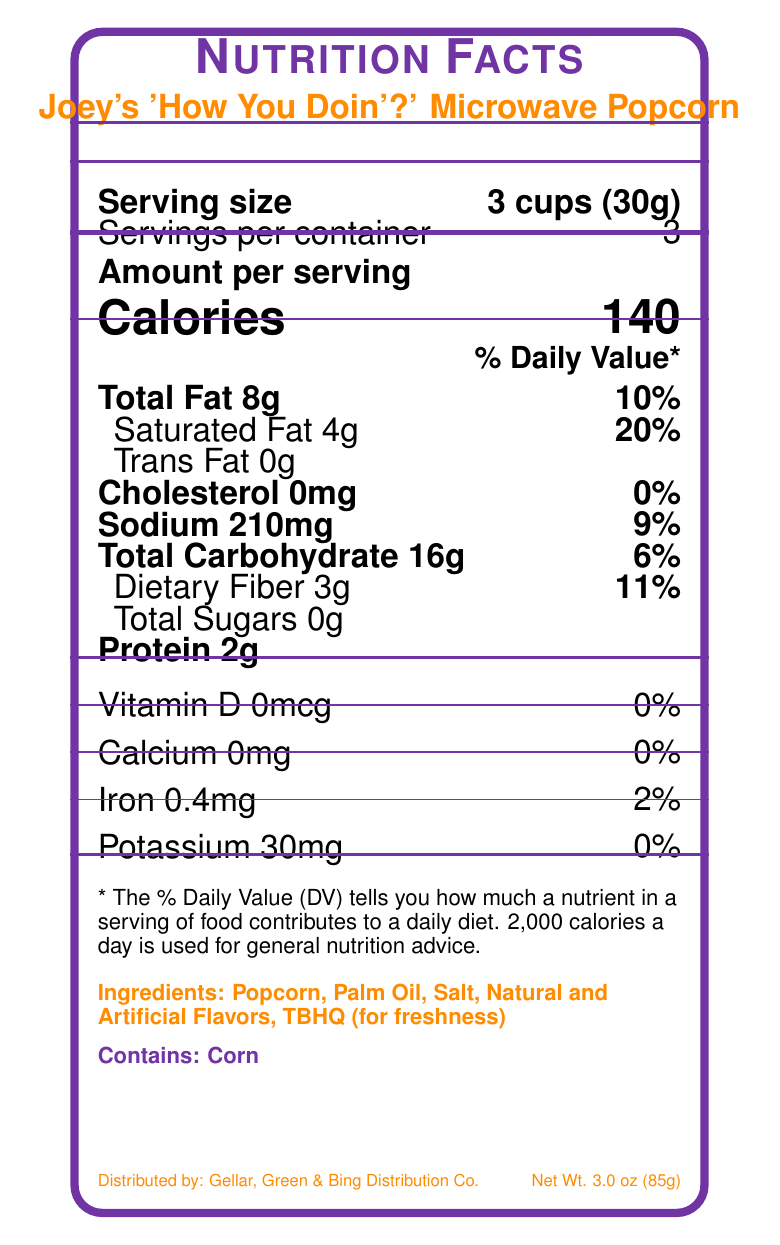how many calories are in one serving of Joey's 'How You Doin'?' Microwave Popcorn? The nutrition facts label states that there are 140 calories per serving.
Answer: 140 what is the serving size for Joey's 'How You Doin'?' Microwave Popcorn? The serving size is listed as 3 cups (30g) on the nutrition facts label.
Answer: 3 cups (30g) how much total fat is in one serving of this popcorn? According to the nutrition facts, each serving contains 8 grams of total fat.
Answer: 8g what percentage of the daily value does saturated fat in one serving represent? The nutrition label indicates that the saturated fat in one serving is 4g, which corresponds to 20% of the daily value.
Answer: 20% how much sodium is in one serving? The nutrition facts state that there are 210 milligrams of sodium in one serving.
Answer: 210mg list all the ingredients in Joey's 'How You Doin'?' Microwave Popcorn The ingredients are provided on the nutrition facts label.
Answer: Popcorn, Palm Oil, Salt, Natural and Artificial Flavors, TBHQ (for freshness) does this product contain any cholesterol? The nutrition facts label shows that there is 0mg of cholesterol.
Answer: No how many servings are in one container? The label clearly mentions that there are 3 servings per container.
Answer: 3 what is the amount of dietary fiber per serving? The nutrition facts indicate that there are 3 grams of dietary fiber per serving.
Answer: 3g what is the product name? The product name is displayed at the top of the nutrition facts label.
Answer: Joey's 'How You Doin'?' Microwave Popcorn which of these vitamins or minerals are present in the highest daily value percentage per serving? A. Vitamin D B. Calcium C. Iron D. Potassium The label shows Iron at 2% daily value, which is higher compared to 0% daily value for Vitamin D, Calcium, and Potassium.
Answer: C which company manufactures Joey's 'How You Doin'?' Microwave Popcorn? A. Central Perk Snacks, Inc. B. Gellar, Green & Bing Distribution Co. C. Joey's Snack Co. The label indicates that the product is manufactured by Central Perk Snacks, Inc.
Answer: A are there any added sugars in the popcorn? (Yes/No) The label states that there are 0 grams of total sugars, indicating no added sugars.
Answer: No summarize the main nutritional information of Joey's 'How You Doin'?' Microwave Popcorn This summary includes the key nutritional information such as serving size, calories, macronutrients, and important vitamins/minerals.
Answer: Each serving of Joey's 'How You Doin'?' Microwave Popcorn is 3 cups (30g) with 140 calories. It contains 8g of total fat, 4g of saturated fat, 210mg of sodium, 16g of total carbohydrates, 3g of dietary fiber, 0g of sugars, and 2g of protein. The product does not contain cholesterol and has minimal vitamin and mineral content. what year was the product released? The document does not provide any information regarding the release year of the product.
Answer: Cannot be determined 